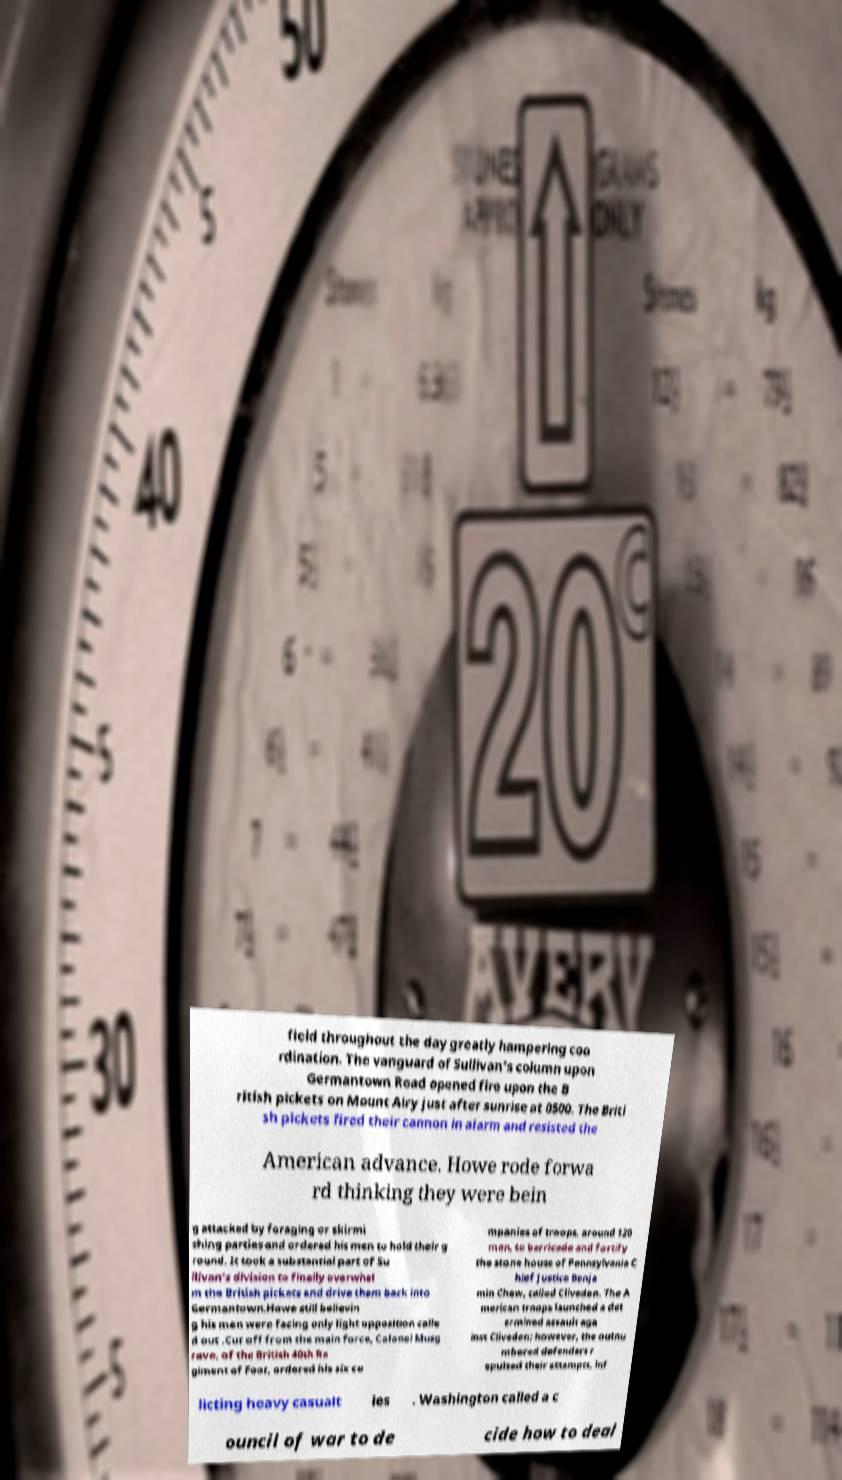For documentation purposes, I need the text within this image transcribed. Could you provide that? field throughout the day greatly hampering coo rdination. The vanguard of Sullivan's column upon Germantown Road opened fire upon the B ritish pickets on Mount Airy just after sunrise at 0500. The Briti sh pickets fired their cannon in alarm and resisted the American advance. Howe rode forwa rd thinking they were bein g attacked by foraging or skirmi shing parties and ordered his men to hold their g round. It took a substantial part of Su llivan's division to finally overwhel m the British pickets and drive them back into Germantown.Howe still believin g his men were facing only light opposition calle d out .Cut off from the main force, Colonel Musg rave, of the British 40th Re giment of Foot, ordered his six co mpanies of troops, around 120 men, to barricade and fortify the stone house of Pennsylvania C hief Justice Benja min Chew, called Cliveden. The A merican troops launched a det ermined assault aga inst Cliveden; however, the outnu mbered defenders r epulsed their attempts, inf licting heavy casualt ies . Washington called a c ouncil of war to de cide how to deal 